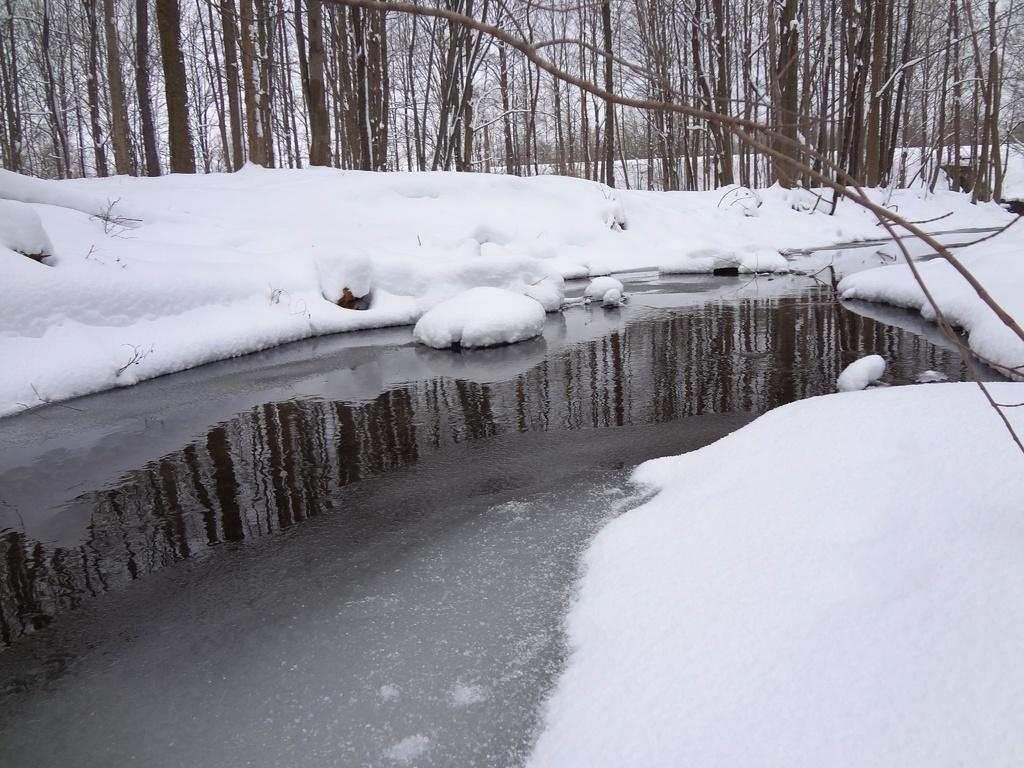What type of vegetation is present in the image? There are many trees in the image. What is the weather like in the image? There is snow in the image, indicating a cold and likely wintery scene. Can you describe the water visible in the image? There is water visible in the bottom left corner of the image. Reasoning: Let' Let's think step by step in order to produce the conversation. We start by identifying the main subject in the image, which is the presence of many trees. Then, we expand the conversation to include the weather, which is indicated by the presence of snow. Finally, we describe the water visible in the image, providing a more detailed description of the scene. Absurd Question/Answer: What type of fowl can be seen walking with the brothers in the image? There are no fowl or brothers present in the image; it features trees, snow, and water. 